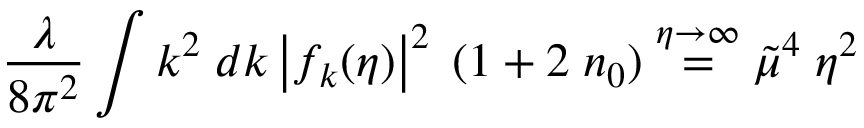<formula> <loc_0><loc_0><loc_500><loc_500>\frac { \lambda } { 8 \pi ^ { 2 } } \int k ^ { 2 } \, d k \left | f _ { k } ( \eta ) \right | ^ { 2 } \, ( 1 + 2 \, n _ { 0 } ) \stackrel { \eta \rightarrow \infty } { = } \tilde { \mu } ^ { 4 } \, \eta ^ { 2 }</formula> 